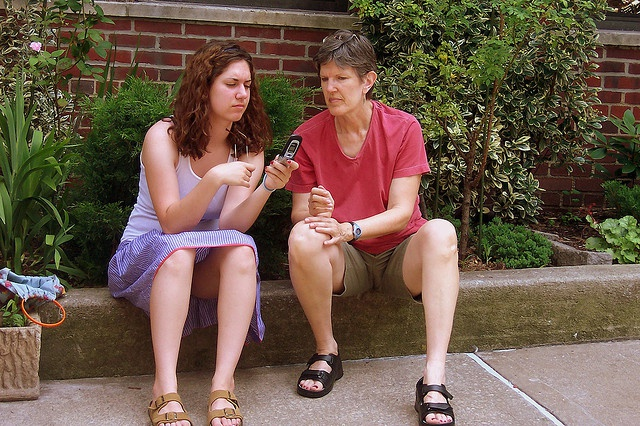Describe the objects in this image and their specific colors. I can see people in gray, lightpink, brown, maroon, and black tones, people in gray, brown, lightpink, and lightgray tones, potted plant in gray and black tones, handbag in gray, maroon, black, darkgray, and lightblue tones, and cell phone in gray, black, darkgray, and darkgreen tones in this image. 